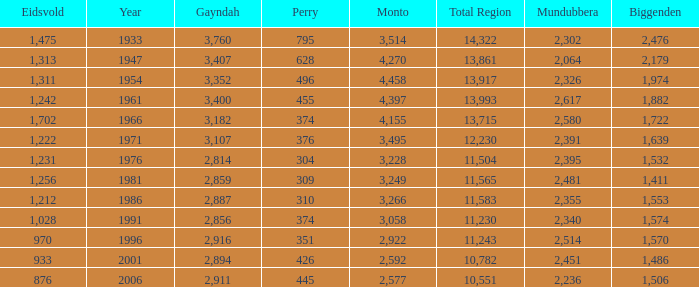What is the Total Region number of hte one that has Eidsvold at 970 and Biggenden larger than 1,570? 0.0. 